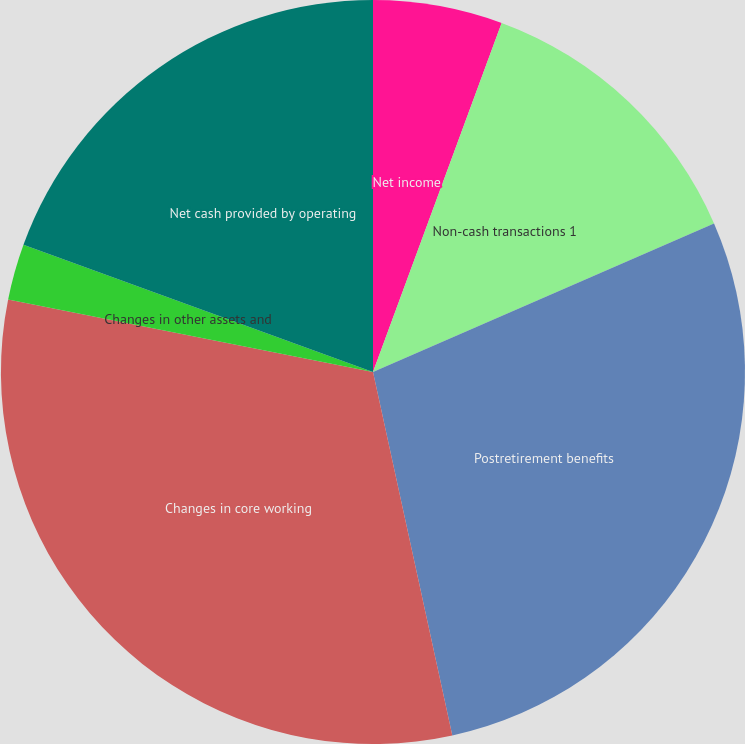Convert chart. <chart><loc_0><loc_0><loc_500><loc_500><pie_chart><fcel>Net income<fcel>Non-cash transactions 1<fcel>Postretirement benefits<fcel>Changes in core working<fcel>Changes in other assets and<fcel>Net cash provided by operating<nl><fcel>5.62%<fcel>12.84%<fcel>28.12%<fcel>31.54%<fcel>2.44%<fcel>19.44%<nl></chart> 